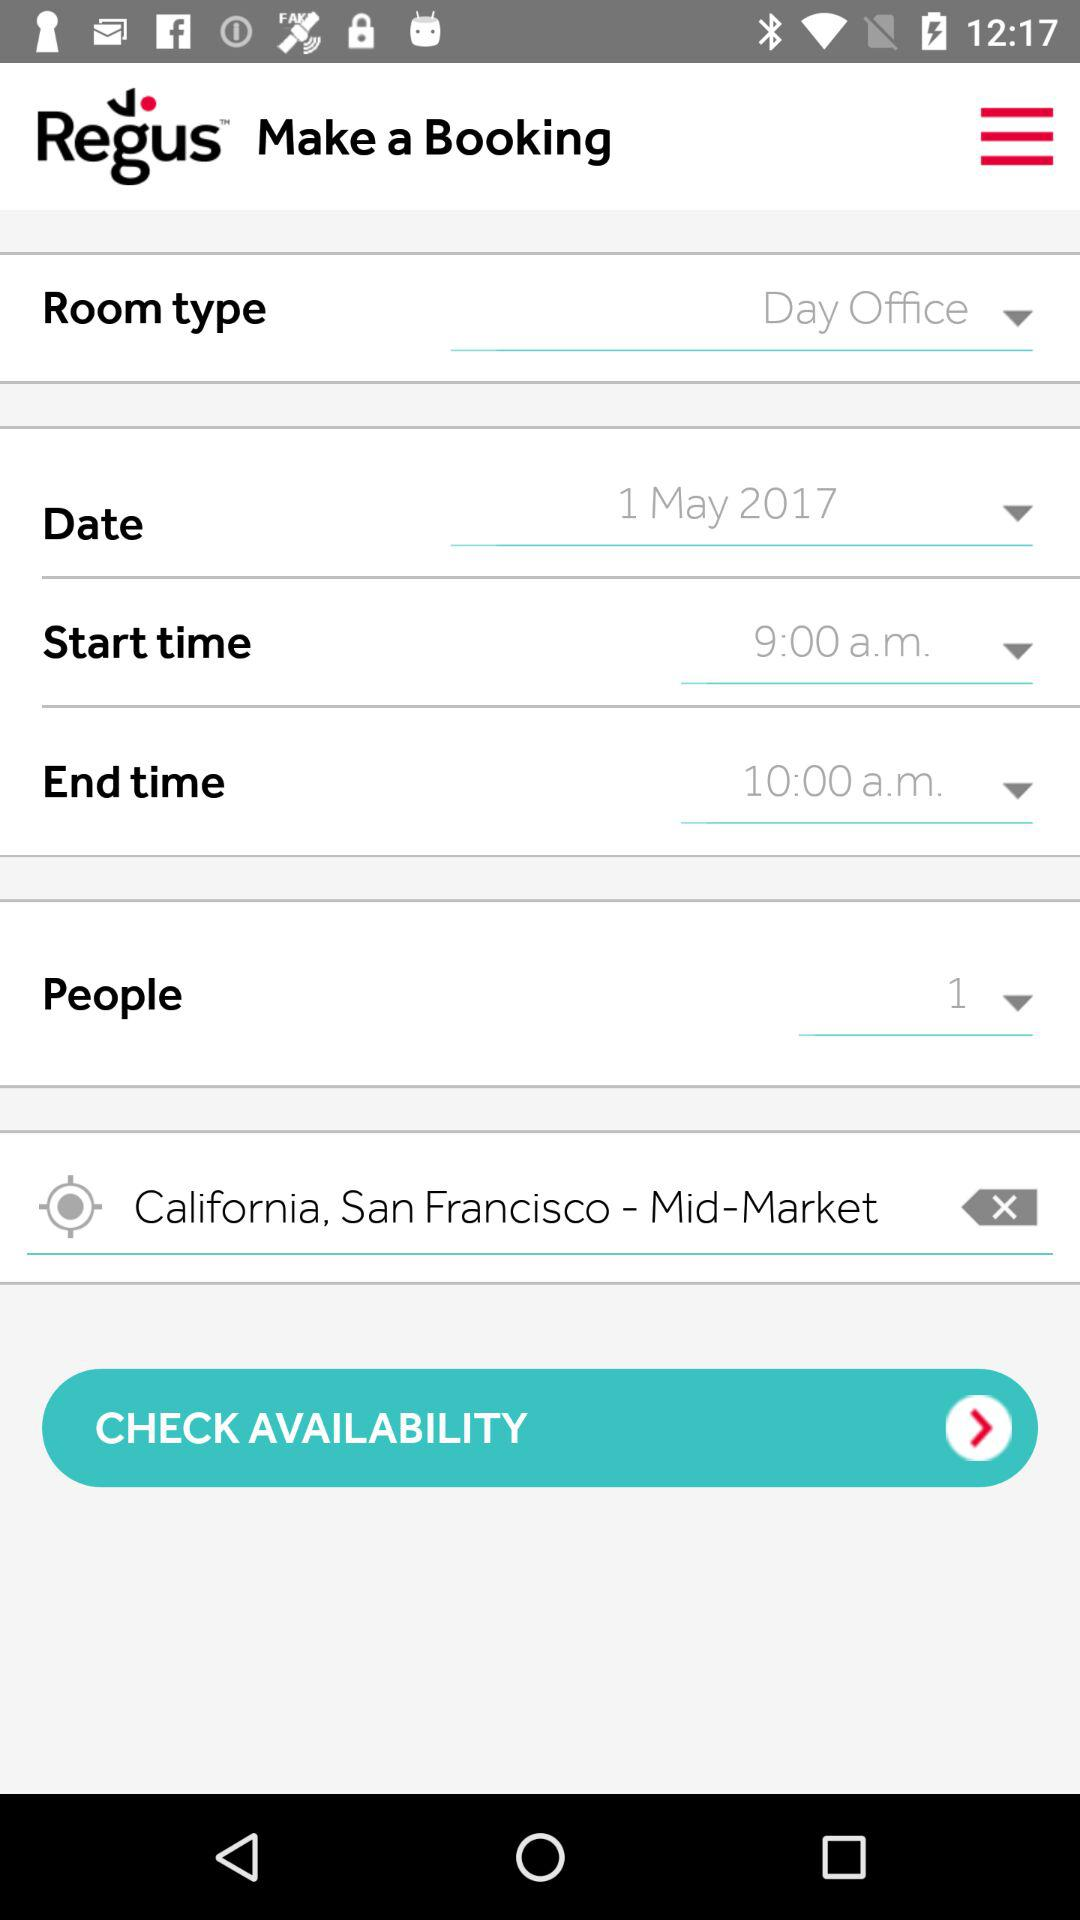What is the start time? The start time is 9:00 a.m. 